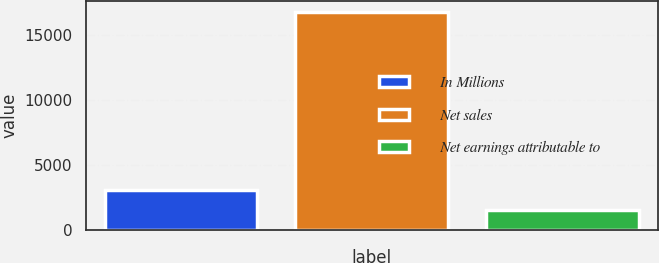Convert chart. <chart><loc_0><loc_0><loc_500><loc_500><bar_chart><fcel>In Millions<fcel>Net sales<fcel>Net earnings attributable to<nl><fcel>3063.47<fcel>16772.9<fcel>1540.2<nl></chart> 